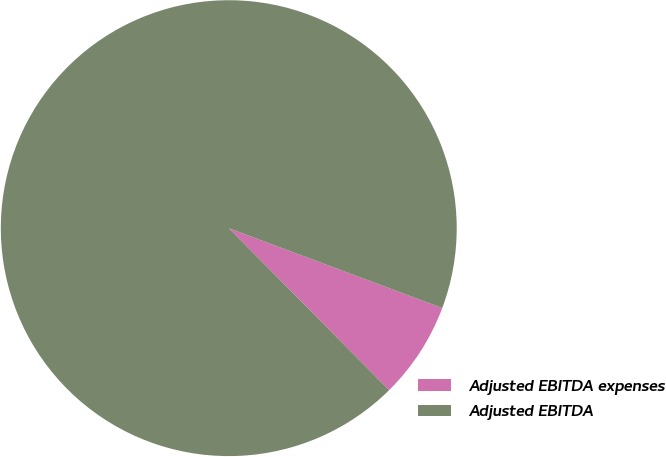Convert chart to OTSL. <chart><loc_0><loc_0><loc_500><loc_500><pie_chart><fcel>Adjusted EBITDA expenses<fcel>Adjusted EBITDA<nl><fcel>6.88%<fcel>93.12%<nl></chart> 